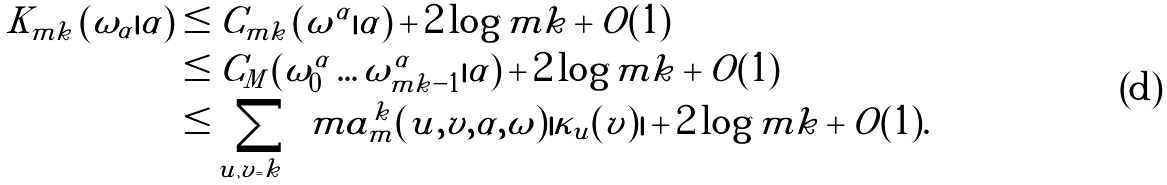<formula> <loc_0><loc_0><loc_500><loc_500>K _ { m k } \left ( \omega _ { \alpha } | \alpha \right ) & \leq C _ { m k } \left ( \omega ^ { \alpha } | \alpha \right ) + 2 \log m k + O ( 1 ) \\ & \leq C _ { M } \left ( \omega ^ { \alpha } _ { 0 } \dots \omega ^ { \alpha } _ { m k - 1 } | \alpha \right ) + 2 \log m k + O ( 1 ) \\ & \leq \sum _ { | u | , | v | = k } m a _ { m } ^ { k } ( u , v , \alpha , \omega ) | \kappa _ { u } ( v ) | + 2 \log m k + O ( 1 ) .</formula> 